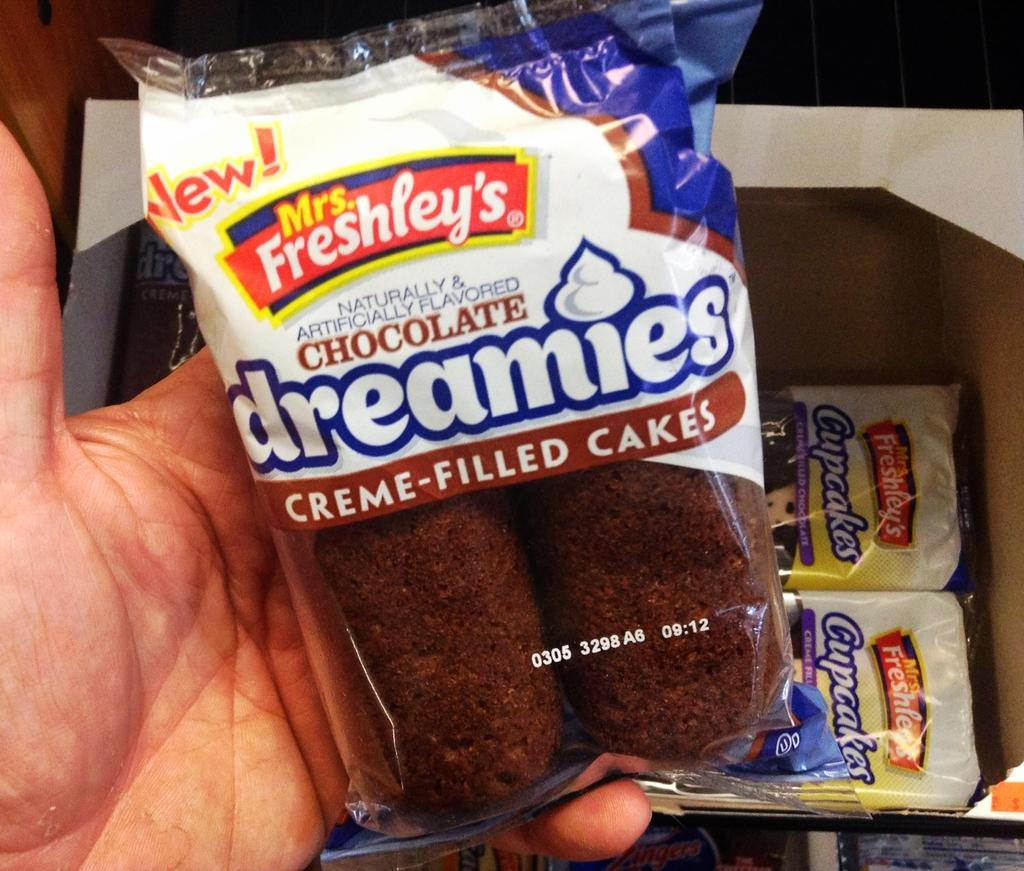Provide a one-sentence caption for the provided image. A plastic package holds two Mrs. Freshley's chocolate creme cakes. 